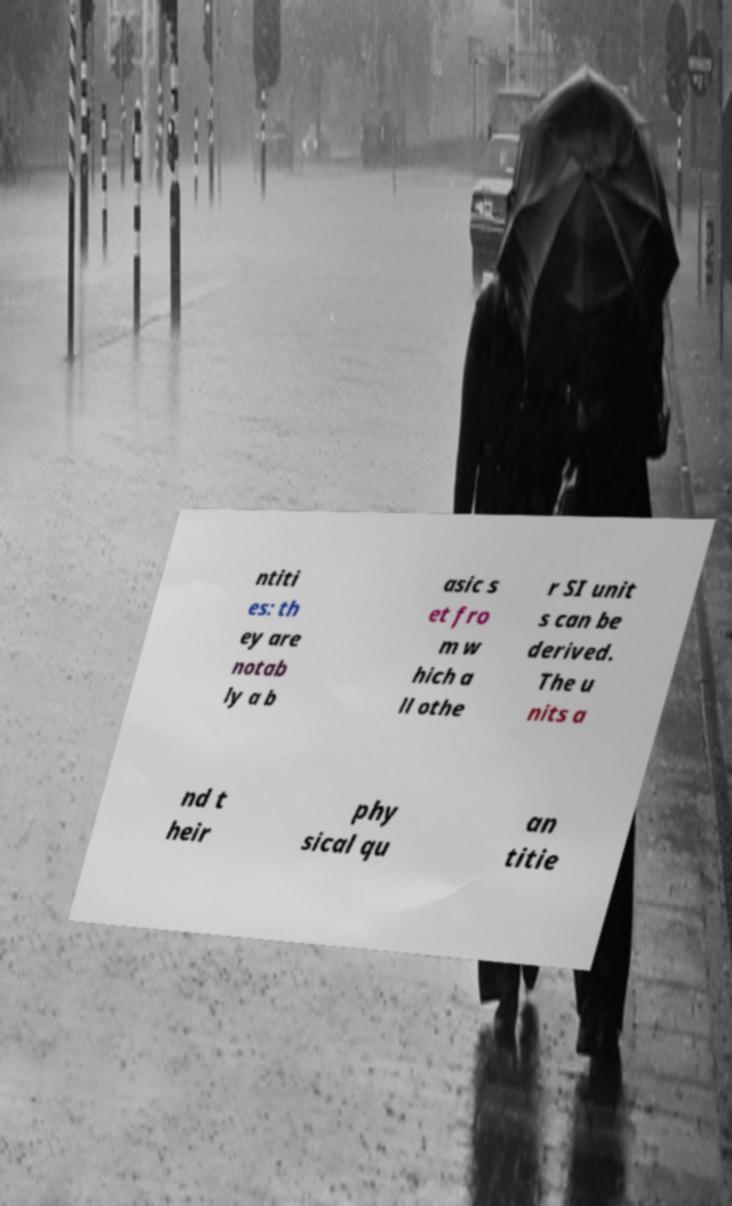Could you assist in decoding the text presented in this image and type it out clearly? ntiti es: th ey are notab ly a b asic s et fro m w hich a ll othe r SI unit s can be derived. The u nits a nd t heir phy sical qu an titie 